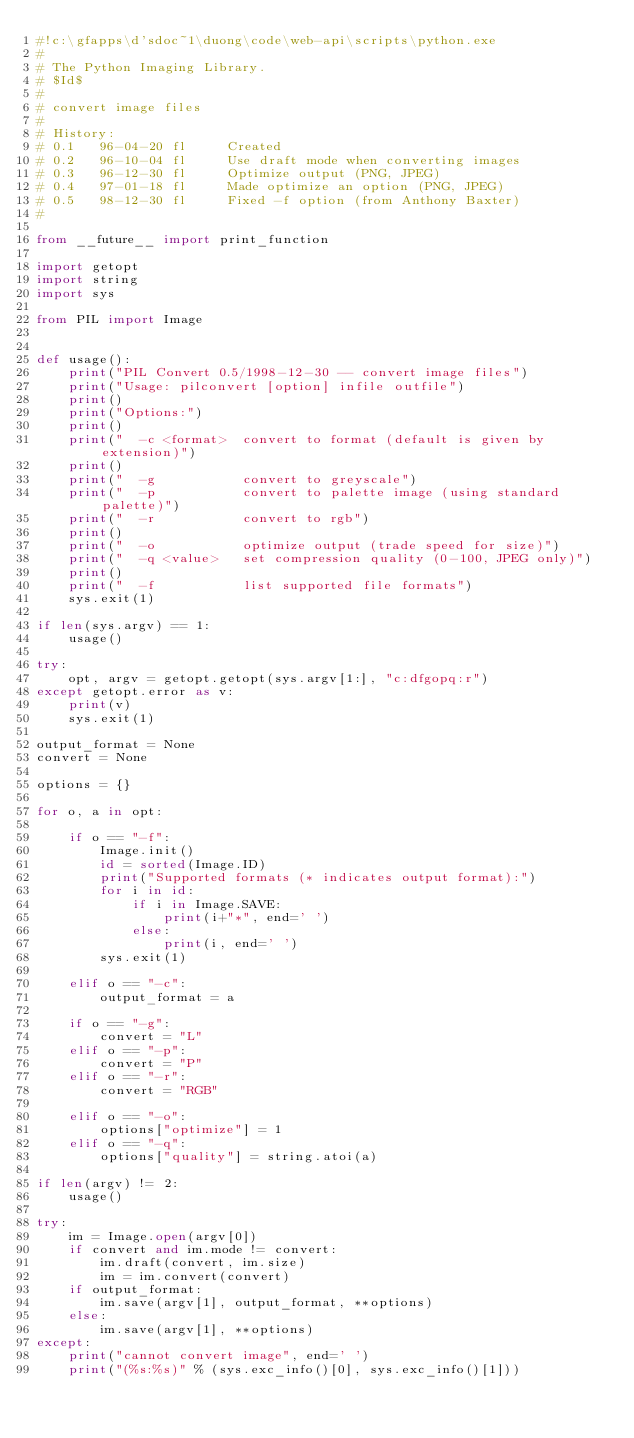Convert code to text. <code><loc_0><loc_0><loc_500><loc_500><_Python_>#!c:\gfapps\d'sdoc~1\duong\code\web-api\scripts\python.exe
#
# The Python Imaging Library.
# $Id$
#
# convert image files
#
# History:
# 0.1   96-04-20 fl     Created
# 0.2   96-10-04 fl     Use draft mode when converting images
# 0.3   96-12-30 fl     Optimize output (PNG, JPEG)
# 0.4   97-01-18 fl     Made optimize an option (PNG, JPEG)
# 0.5   98-12-30 fl     Fixed -f option (from Anthony Baxter)
#

from __future__ import print_function

import getopt
import string
import sys

from PIL import Image


def usage():
    print("PIL Convert 0.5/1998-12-30 -- convert image files")
    print("Usage: pilconvert [option] infile outfile")
    print()
    print("Options:")
    print()
    print("  -c <format>  convert to format (default is given by extension)")
    print()
    print("  -g           convert to greyscale")
    print("  -p           convert to palette image (using standard palette)")
    print("  -r           convert to rgb")
    print()
    print("  -o           optimize output (trade speed for size)")
    print("  -q <value>   set compression quality (0-100, JPEG only)")
    print()
    print("  -f           list supported file formats")
    sys.exit(1)

if len(sys.argv) == 1:
    usage()

try:
    opt, argv = getopt.getopt(sys.argv[1:], "c:dfgopq:r")
except getopt.error as v:
    print(v)
    sys.exit(1)

output_format = None
convert = None

options = {}

for o, a in opt:

    if o == "-f":
        Image.init()
        id = sorted(Image.ID)
        print("Supported formats (* indicates output format):")
        for i in id:
            if i in Image.SAVE:
                print(i+"*", end=' ')
            else:
                print(i, end=' ')
        sys.exit(1)

    elif o == "-c":
        output_format = a

    if o == "-g":
        convert = "L"
    elif o == "-p":
        convert = "P"
    elif o == "-r":
        convert = "RGB"

    elif o == "-o":
        options["optimize"] = 1
    elif o == "-q":
        options["quality"] = string.atoi(a)

if len(argv) != 2:
    usage()

try:
    im = Image.open(argv[0])
    if convert and im.mode != convert:
        im.draft(convert, im.size)
        im = im.convert(convert)
    if output_format:
        im.save(argv[1], output_format, **options)
    else:
        im.save(argv[1], **options)
except:
    print("cannot convert image", end=' ')
    print("(%s:%s)" % (sys.exc_info()[0], sys.exc_info()[1]))
</code> 